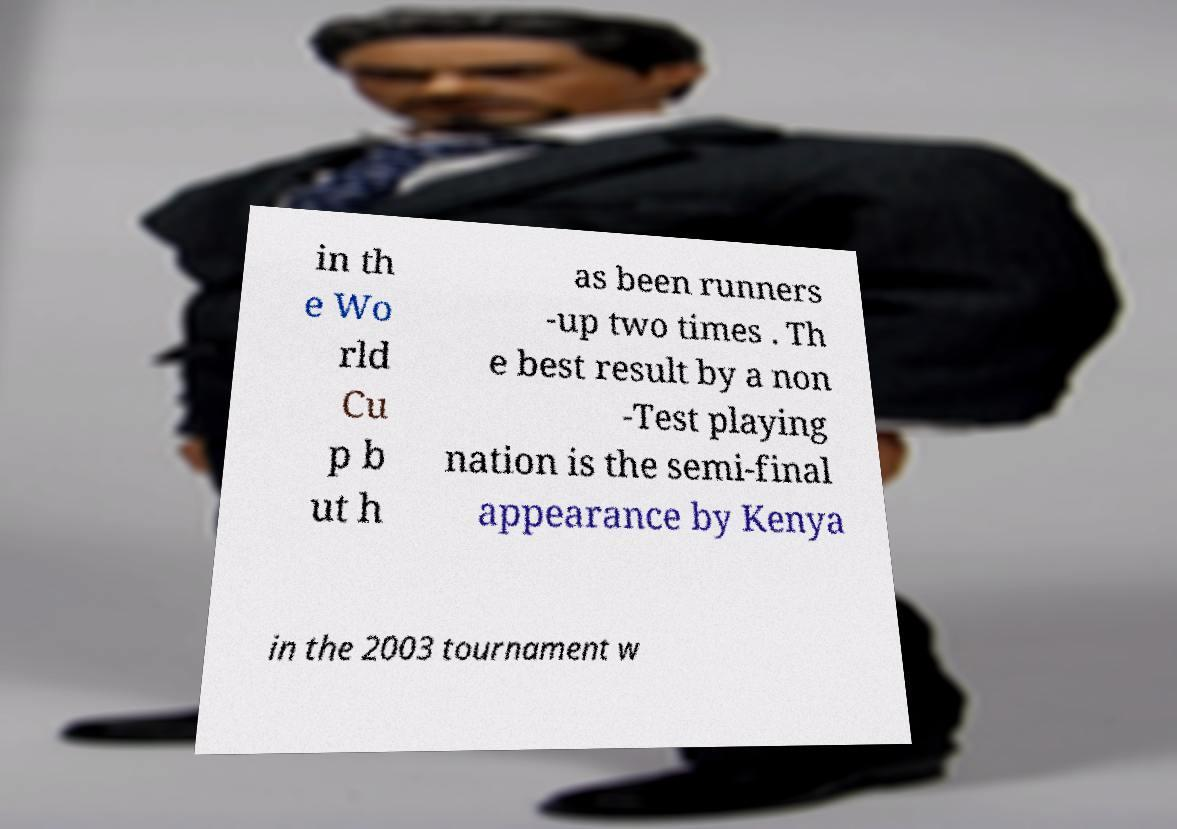For documentation purposes, I need the text within this image transcribed. Could you provide that? in th e Wo rld Cu p b ut h as been runners -up two times . Th e best result by a non -Test playing nation is the semi-final appearance by Kenya in the 2003 tournament w 